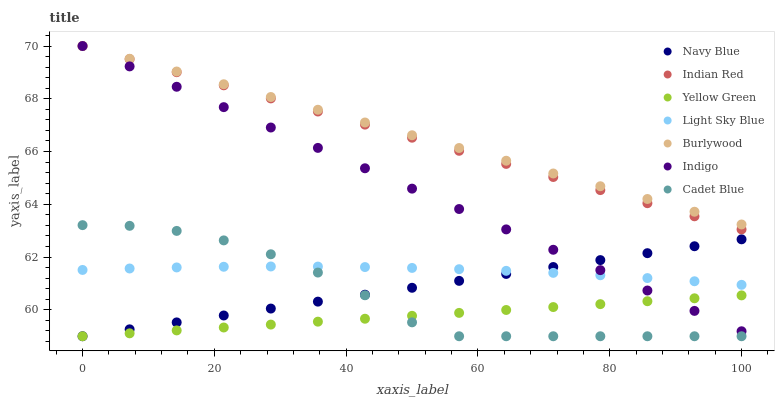Does Yellow Green have the minimum area under the curve?
Answer yes or no. Yes. Does Burlywood have the maximum area under the curve?
Answer yes or no. Yes. Does Indigo have the minimum area under the curve?
Answer yes or no. No. Does Indigo have the maximum area under the curve?
Answer yes or no. No. Is Navy Blue the smoothest?
Answer yes or no. Yes. Is Cadet Blue the roughest?
Answer yes or no. Yes. Is Indigo the smoothest?
Answer yes or no. No. Is Indigo the roughest?
Answer yes or no. No. Does Cadet Blue have the lowest value?
Answer yes or no. Yes. Does Indigo have the lowest value?
Answer yes or no. No. Does Indian Red have the highest value?
Answer yes or no. Yes. Does Yellow Green have the highest value?
Answer yes or no. No. Is Cadet Blue less than Indigo?
Answer yes or no. Yes. Is Indian Red greater than Yellow Green?
Answer yes or no. Yes. Does Light Sky Blue intersect Navy Blue?
Answer yes or no. Yes. Is Light Sky Blue less than Navy Blue?
Answer yes or no. No. Is Light Sky Blue greater than Navy Blue?
Answer yes or no. No. Does Cadet Blue intersect Indigo?
Answer yes or no. No. 